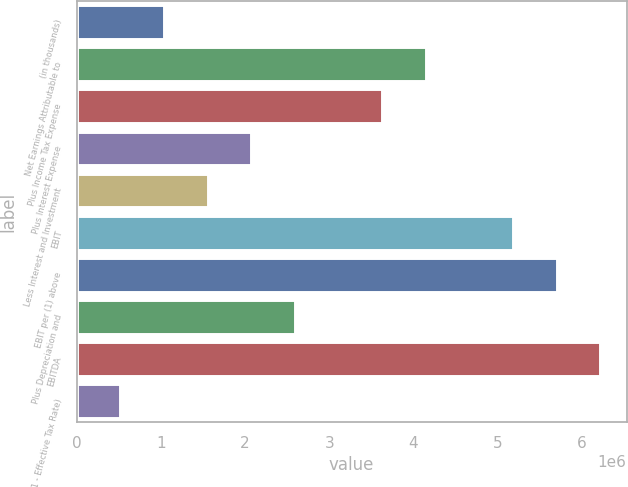<chart> <loc_0><loc_0><loc_500><loc_500><bar_chart><fcel>(in thousands)<fcel>Net Earnings Attributable to<fcel>Plus Income Tax Expense<fcel>Plus Interest Expense<fcel>Less Interest and Investment<fcel>EBIT<fcel>EBIT per (1) above<fcel>Plus Depreciation and<fcel>EBITDA<fcel>X (1 - Effective Tax Rate)<nl><fcel>1.03719e+06<fcel>4.14873e+06<fcel>3.63014e+06<fcel>2.07437e+06<fcel>1.55578e+06<fcel>5.18591e+06<fcel>5.7045e+06<fcel>2.59296e+06<fcel>6.22309e+06<fcel>518605<nl></chart> 